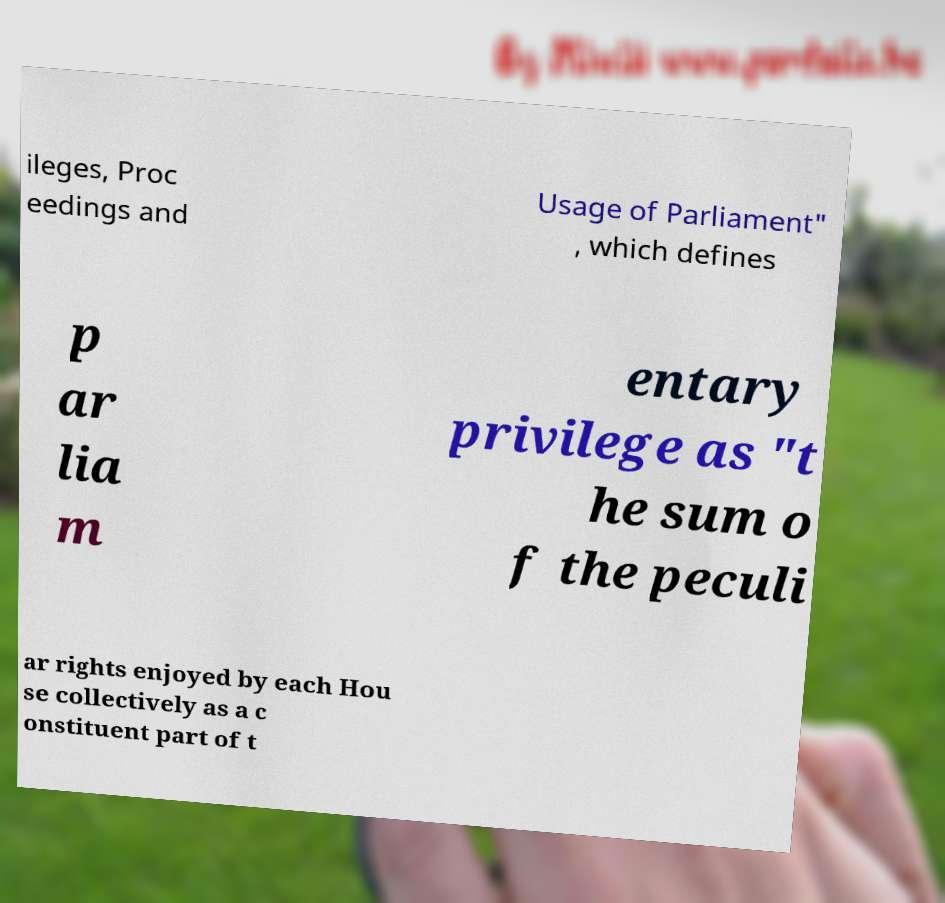For documentation purposes, I need the text within this image transcribed. Could you provide that? ileges, Proc eedings and Usage of Parliament" , which defines p ar lia m entary privilege as "t he sum o f the peculi ar rights enjoyed by each Hou se collectively as a c onstituent part of t 